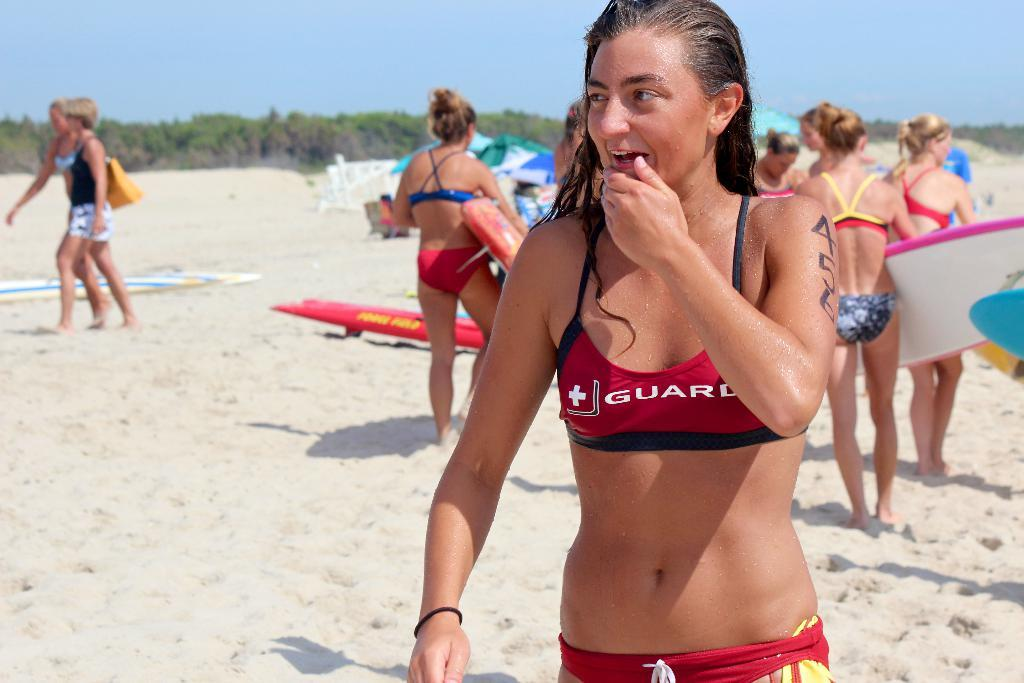<image>
Relay a brief, clear account of the picture shown. a lady in an outfit that says guard on it 